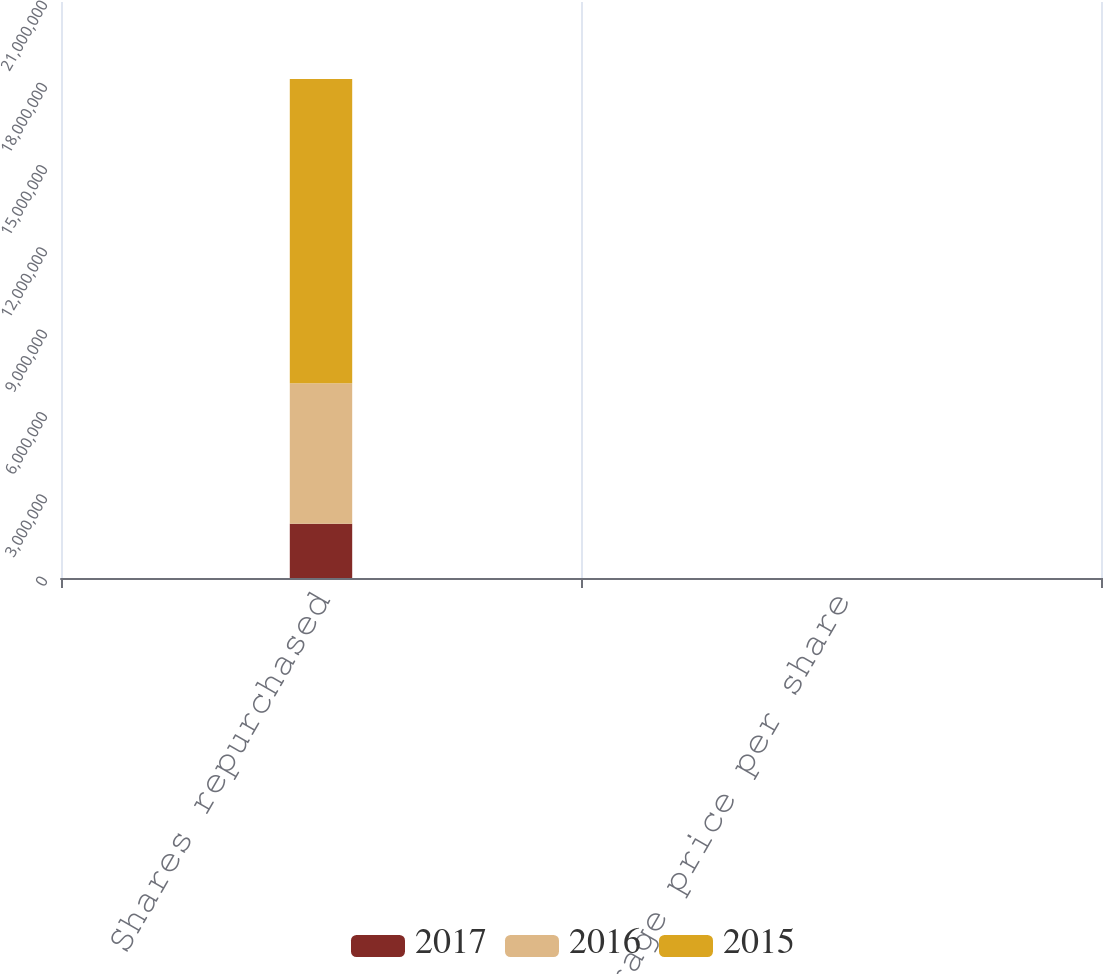Convert chart. <chart><loc_0><loc_0><loc_500><loc_500><stacked_bar_chart><ecel><fcel>Shares repurchased<fcel>Average price per share<nl><fcel>2017<fcel>1.97678e+06<fcel>133.9<nl><fcel>2016<fcel>5.12105e+06<fcel>108.87<nl><fcel>2015<fcel>1.10918e+07<fcel>125.64<nl></chart> 